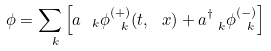<formula> <loc_0><loc_0><loc_500><loc_500>\phi = \sum _ { \ k } \left [ a _ { \ k } \phi ^ { ( + ) } _ { \ k } ( t , \ x ) + a ^ { \dagger } _ { \ k } \phi ^ { ( - ) } _ { \ k } \right ]</formula> 